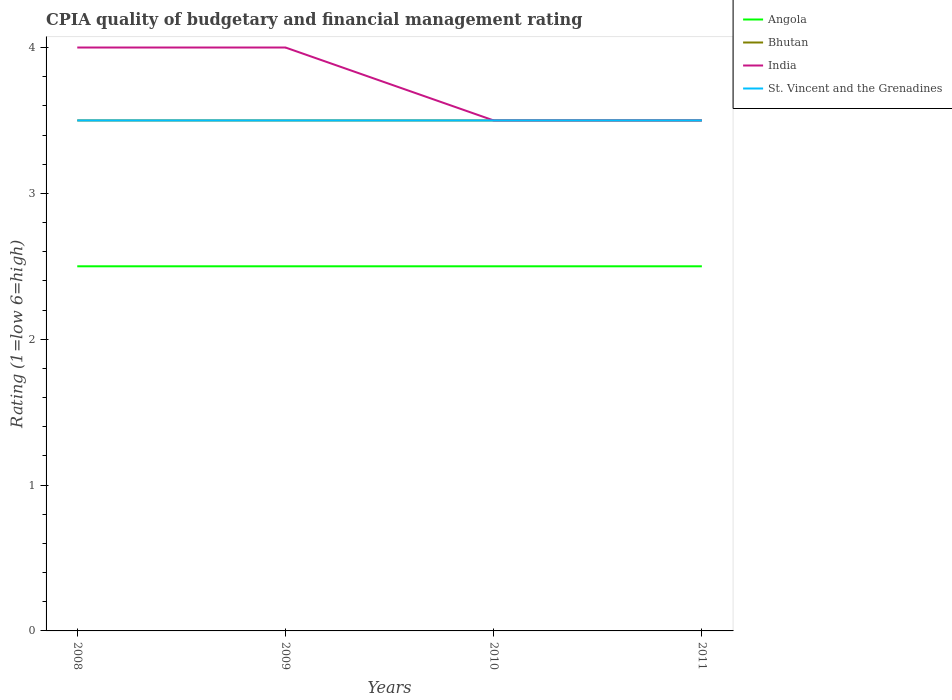Does the line corresponding to St. Vincent and the Grenadines intersect with the line corresponding to India?
Your answer should be compact. Yes. Is the number of lines equal to the number of legend labels?
Your answer should be very brief. Yes. What is the difference between the highest and the lowest CPIA rating in St. Vincent and the Grenadines?
Offer a very short reply. 0. How many years are there in the graph?
Offer a terse response. 4. What is the difference between two consecutive major ticks on the Y-axis?
Give a very brief answer. 1. Are the values on the major ticks of Y-axis written in scientific E-notation?
Give a very brief answer. No. Does the graph contain any zero values?
Ensure brevity in your answer.  No. Does the graph contain grids?
Keep it short and to the point. No. How are the legend labels stacked?
Give a very brief answer. Vertical. What is the title of the graph?
Provide a succinct answer. CPIA quality of budgetary and financial management rating. Does "Algeria" appear as one of the legend labels in the graph?
Provide a short and direct response. No. What is the label or title of the X-axis?
Provide a succinct answer. Years. What is the Rating (1=low 6=high) of Angola in 2008?
Your response must be concise. 2.5. What is the Rating (1=low 6=high) of Bhutan in 2008?
Provide a short and direct response. 3.5. What is the Rating (1=low 6=high) of St. Vincent and the Grenadines in 2008?
Your answer should be very brief. 3.5. What is the Rating (1=low 6=high) in Bhutan in 2009?
Make the answer very short. 3.5. What is the Rating (1=low 6=high) of India in 2009?
Offer a terse response. 4. What is the Rating (1=low 6=high) in St. Vincent and the Grenadines in 2009?
Ensure brevity in your answer.  3.5. What is the Rating (1=low 6=high) of Angola in 2010?
Make the answer very short. 2.5. What is the Rating (1=low 6=high) of Bhutan in 2010?
Your answer should be very brief. 3.5. What is the Rating (1=low 6=high) in India in 2010?
Your response must be concise. 3.5. Across all years, what is the maximum Rating (1=low 6=high) of India?
Provide a short and direct response. 4. Across all years, what is the maximum Rating (1=low 6=high) of St. Vincent and the Grenadines?
Your response must be concise. 3.5. Across all years, what is the minimum Rating (1=low 6=high) of Bhutan?
Your answer should be compact. 3.5. Across all years, what is the minimum Rating (1=low 6=high) in St. Vincent and the Grenadines?
Your answer should be compact. 3.5. What is the total Rating (1=low 6=high) of Angola in the graph?
Provide a short and direct response. 10. What is the total Rating (1=low 6=high) in Bhutan in the graph?
Ensure brevity in your answer.  14. What is the total Rating (1=low 6=high) of St. Vincent and the Grenadines in the graph?
Your answer should be compact. 14. What is the difference between the Rating (1=low 6=high) of Bhutan in 2008 and that in 2009?
Your response must be concise. 0. What is the difference between the Rating (1=low 6=high) of Angola in 2008 and that in 2010?
Your answer should be compact. 0. What is the difference between the Rating (1=low 6=high) in Bhutan in 2008 and that in 2010?
Ensure brevity in your answer.  0. What is the difference between the Rating (1=low 6=high) of India in 2008 and that in 2010?
Give a very brief answer. 0.5. What is the difference between the Rating (1=low 6=high) of Angola in 2008 and that in 2011?
Provide a short and direct response. 0. What is the difference between the Rating (1=low 6=high) of India in 2008 and that in 2011?
Ensure brevity in your answer.  0.5. What is the difference between the Rating (1=low 6=high) in Angola in 2009 and that in 2010?
Make the answer very short. 0. What is the difference between the Rating (1=low 6=high) of St. Vincent and the Grenadines in 2009 and that in 2010?
Your answer should be compact. 0. What is the difference between the Rating (1=low 6=high) in Bhutan in 2009 and that in 2011?
Ensure brevity in your answer.  0. What is the difference between the Rating (1=low 6=high) in India in 2009 and that in 2011?
Provide a succinct answer. 0.5. What is the difference between the Rating (1=low 6=high) in St. Vincent and the Grenadines in 2009 and that in 2011?
Offer a terse response. 0. What is the difference between the Rating (1=low 6=high) of Bhutan in 2010 and that in 2011?
Ensure brevity in your answer.  0. What is the difference between the Rating (1=low 6=high) of India in 2010 and that in 2011?
Ensure brevity in your answer.  0. What is the difference between the Rating (1=low 6=high) in St. Vincent and the Grenadines in 2010 and that in 2011?
Keep it short and to the point. 0. What is the difference between the Rating (1=low 6=high) in Angola in 2008 and the Rating (1=low 6=high) in India in 2009?
Ensure brevity in your answer.  -1.5. What is the difference between the Rating (1=low 6=high) of Angola in 2008 and the Rating (1=low 6=high) of St. Vincent and the Grenadines in 2009?
Provide a succinct answer. -1. What is the difference between the Rating (1=low 6=high) in Bhutan in 2008 and the Rating (1=low 6=high) in India in 2009?
Offer a terse response. -0.5. What is the difference between the Rating (1=low 6=high) of Angola in 2008 and the Rating (1=low 6=high) of Bhutan in 2010?
Offer a terse response. -1. What is the difference between the Rating (1=low 6=high) in Angola in 2008 and the Rating (1=low 6=high) in St. Vincent and the Grenadines in 2010?
Ensure brevity in your answer.  -1. What is the difference between the Rating (1=low 6=high) in Bhutan in 2008 and the Rating (1=low 6=high) in India in 2010?
Provide a short and direct response. 0. What is the difference between the Rating (1=low 6=high) of India in 2008 and the Rating (1=low 6=high) of St. Vincent and the Grenadines in 2010?
Give a very brief answer. 0.5. What is the difference between the Rating (1=low 6=high) in Angola in 2008 and the Rating (1=low 6=high) in India in 2011?
Give a very brief answer. -1. What is the difference between the Rating (1=low 6=high) of Angola in 2008 and the Rating (1=low 6=high) of St. Vincent and the Grenadines in 2011?
Your answer should be very brief. -1. What is the difference between the Rating (1=low 6=high) in Bhutan in 2008 and the Rating (1=low 6=high) in India in 2011?
Make the answer very short. 0. What is the difference between the Rating (1=low 6=high) in Bhutan in 2008 and the Rating (1=low 6=high) in St. Vincent and the Grenadines in 2011?
Give a very brief answer. 0. What is the difference between the Rating (1=low 6=high) in India in 2008 and the Rating (1=low 6=high) in St. Vincent and the Grenadines in 2011?
Your response must be concise. 0.5. What is the difference between the Rating (1=low 6=high) in Bhutan in 2009 and the Rating (1=low 6=high) in St. Vincent and the Grenadines in 2010?
Make the answer very short. 0. What is the difference between the Rating (1=low 6=high) in India in 2009 and the Rating (1=low 6=high) in St. Vincent and the Grenadines in 2010?
Your answer should be very brief. 0.5. What is the difference between the Rating (1=low 6=high) in Angola in 2009 and the Rating (1=low 6=high) in Bhutan in 2011?
Offer a very short reply. -1. What is the difference between the Rating (1=low 6=high) in Angola in 2009 and the Rating (1=low 6=high) in India in 2011?
Offer a very short reply. -1. What is the difference between the Rating (1=low 6=high) of Angola in 2009 and the Rating (1=low 6=high) of St. Vincent and the Grenadines in 2011?
Your response must be concise. -1. What is the difference between the Rating (1=low 6=high) of Bhutan in 2009 and the Rating (1=low 6=high) of India in 2011?
Provide a succinct answer. 0. What is the difference between the Rating (1=low 6=high) in Bhutan in 2009 and the Rating (1=low 6=high) in St. Vincent and the Grenadines in 2011?
Your answer should be very brief. 0. What is the difference between the Rating (1=low 6=high) in Angola in 2010 and the Rating (1=low 6=high) in Bhutan in 2011?
Offer a terse response. -1. What is the difference between the Rating (1=low 6=high) of Bhutan in 2010 and the Rating (1=low 6=high) of India in 2011?
Ensure brevity in your answer.  0. What is the difference between the Rating (1=low 6=high) of Bhutan in 2010 and the Rating (1=low 6=high) of St. Vincent and the Grenadines in 2011?
Give a very brief answer. 0. What is the difference between the Rating (1=low 6=high) in India in 2010 and the Rating (1=low 6=high) in St. Vincent and the Grenadines in 2011?
Ensure brevity in your answer.  0. What is the average Rating (1=low 6=high) of Angola per year?
Your answer should be very brief. 2.5. What is the average Rating (1=low 6=high) of India per year?
Offer a very short reply. 3.75. What is the average Rating (1=low 6=high) of St. Vincent and the Grenadines per year?
Make the answer very short. 3.5. In the year 2008, what is the difference between the Rating (1=low 6=high) of Bhutan and Rating (1=low 6=high) of India?
Make the answer very short. -0.5. In the year 2009, what is the difference between the Rating (1=low 6=high) of Angola and Rating (1=low 6=high) of St. Vincent and the Grenadines?
Offer a very short reply. -1. In the year 2009, what is the difference between the Rating (1=low 6=high) of Bhutan and Rating (1=low 6=high) of India?
Provide a succinct answer. -0.5. In the year 2009, what is the difference between the Rating (1=low 6=high) in Bhutan and Rating (1=low 6=high) in St. Vincent and the Grenadines?
Keep it short and to the point. 0. In the year 2010, what is the difference between the Rating (1=low 6=high) in Angola and Rating (1=low 6=high) in India?
Your answer should be very brief. -1. In the year 2010, what is the difference between the Rating (1=low 6=high) of Bhutan and Rating (1=low 6=high) of India?
Make the answer very short. 0. In the year 2010, what is the difference between the Rating (1=low 6=high) in Bhutan and Rating (1=low 6=high) in St. Vincent and the Grenadines?
Your response must be concise. 0. In the year 2010, what is the difference between the Rating (1=low 6=high) in India and Rating (1=low 6=high) in St. Vincent and the Grenadines?
Ensure brevity in your answer.  0. In the year 2011, what is the difference between the Rating (1=low 6=high) in Angola and Rating (1=low 6=high) in India?
Keep it short and to the point. -1. In the year 2011, what is the difference between the Rating (1=low 6=high) in Angola and Rating (1=low 6=high) in St. Vincent and the Grenadines?
Make the answer very short. -1. In the year 2011, what is the difference between the Rating (1=low 6=high) of Bhutan and Rating (1=low 6=high) of St. Vincent and the Grenadines?
Give a very brief answer. 0. In the year 2011, what is the difference between the Rating (1=low 6=high) in India and Rating (1=low 6=high) in St. Vincent and the Grenadines?
Ensure brevity in your answer.  0. What is the ratio of the Rating (1=low 6=high) in Angola in 2008 to that in 2009?
Offer a very short reply. 1. What is the ratio of the Rating (1=low 6=high) of Bhutan in 2008 to that in 2009?
Offer a very short reply. 1. What is the ratio of the Rating (1=low 6=high) in India in 2008 to that in 2009?
Ensure brevity in your answer.  1. What is the ratio of the Rating (1=low 6=high) in India in 2008 to that in 2010?
Ensure brevity in your answer.  1.14. What is the ratio of the Rating (1=low 6=high) of Bhutan in 2009 to that in 2010?
Give a very brief answer. 1. What is the ratio of the Rating (1=low 6=high) of India in 2009 to that in 2010?
Give a very brief answer. 1.14. What is the ratio of the Rating (1=low 6=high) of St. Vincent and the Grenadines in 2009 to that in 2010?
Provide a short and direct response. 1. What is the ratio of the Rating (1=low 6=high) of Angola in 2009 to that in 2011?
Make the answer very short. 1. What is the ratio of the Rating (1=low 6=high) in Bhutan in 2009 to that in 2011?
Provide a succinct answer. 1. What is the ratio of the Rating (1=low 6=high) of India in 2009 to that in 2011?
Your answer should be compact. 1.14. What is the ratio of the Rating (1=low 6=high) of St. Vincent and the Grenadines in 2009 to that in 2011?
Provide a succinct answer. 1. What is the ratio of the Rating (1=low 6=high) of Angola in 2010 to that in 2011?
Your answer should be very brief. 1. What is the ratio of the Rating (1=low 6=high) of India in 2010 to that in 2011?
Provide a succinct answer. 1. What is the difference between the highest and the second highest Rating (1=low 6=high) of Bhutan?
Offer a very short reply. 0. What is the difference between the highest and the lowest Rating (1=low 6=high) of Angola?
Offer a terse response. 0. What is the difference between the highest and the lowest Rating (1=low 6=high) of Bhutan?
Give a very brief answer. 0. 